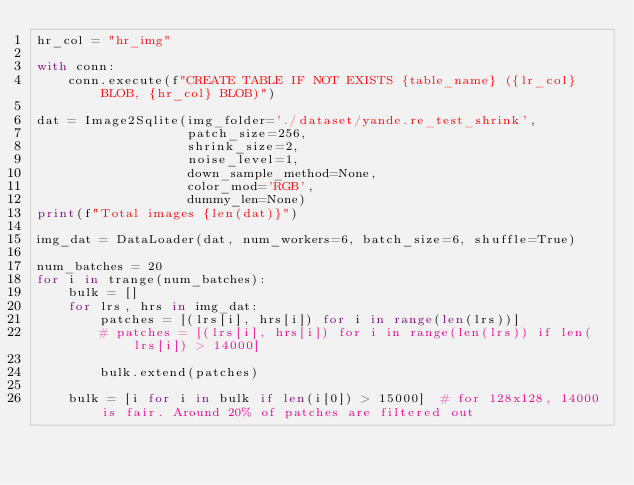<code> <loc_0><loc_0><loc_500><loc_500><_Python_>hr_col = "hr_img"

with conn:
    conn.execute(f"CREATE TABLE IF NOT EXISTS {table_name} ({lr_col} BLOB, {hr_col} BLOB)")

dat = Image2Sqlite(img_folder='./dataset/yande.re_test_shrink',
                   patch_size=256,
                   shrink_size=2,
                   noise_level=1,
                   down_sample_method=None,
                   color_mod='RGB',
                   dummy_len=None)
print(f"Total images {len(dat)}")

img_dat = DataLoader(dat, num_workers=6, batch_size=6, shuffle=True)

num_batches = 20
for i in trange(num_batches):
    bulk = []
    for lrs, hrs in img_dat:
        patches = [(lrs[i], hrs[i]) for i in range(len(lrs))]
        # patches = [(lrs[i], hrs[i]) for i in range(len(lrs)) if len(lrs[i]) > 14000]

        bulk.extend(patches)

    bulk = [i for i in bulk if len(i[0]) > 15000]  # for 128x128, 14000 is fair. Around 20% of patches are filtered out</code> 